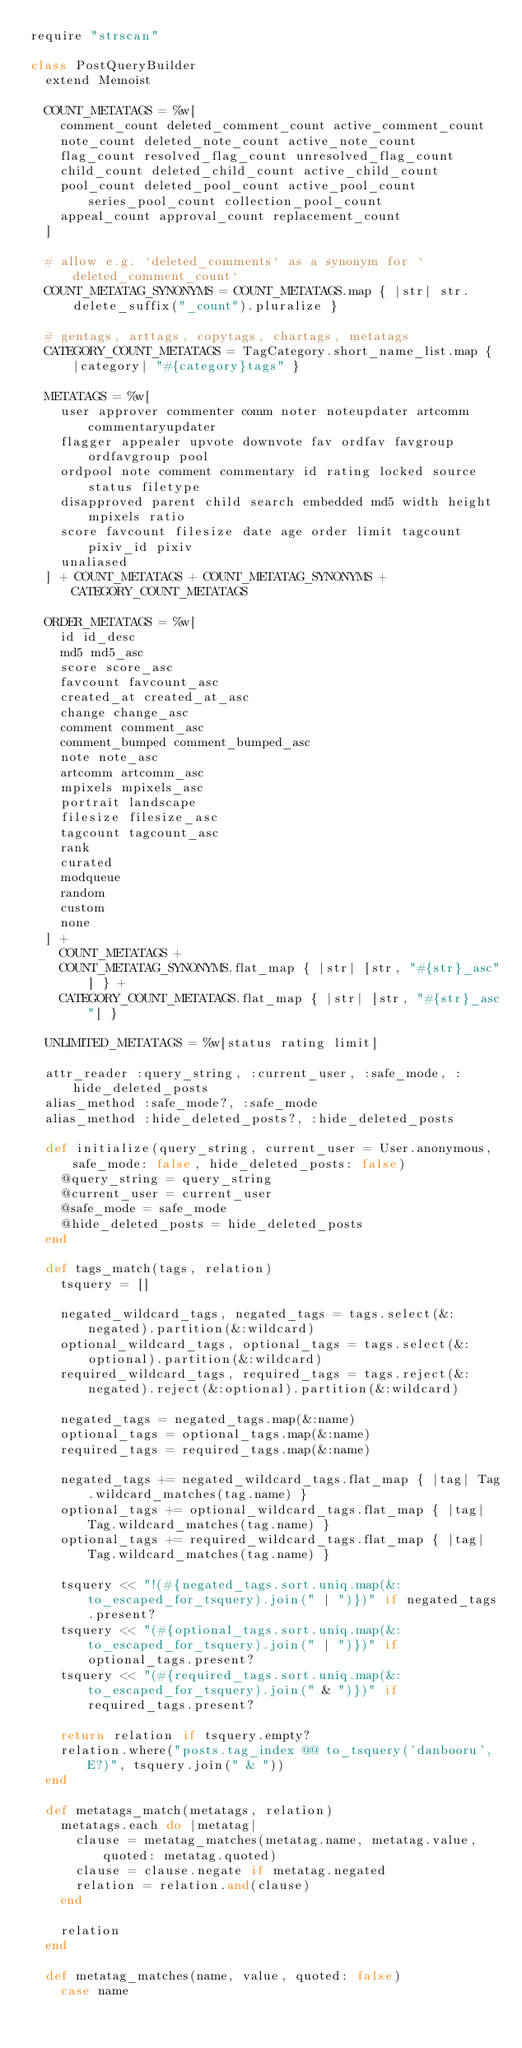Convert code to text. <code><loc_0><loc_0><loc_500><loc_500><_Ruby_>require "strscan"

class PostQueryBuilder
  extend Memoist

  COUNT_METATAGS = %w[
    comment_count deleted_comment_count active_comment_count
    note_count deleted_note_count active_note_count
    flag_count resolved_flag_count unresolved_flag_count
    child_count deleted_child_count active_child_count
    pool_count deleted_pool_count active_pool_count series_pool_count collection_pool_count
    appeal_count approval_count replacement_count
  ]

  # allow e.g. `deleted_comments` as a synonym for `deleted_comment_count`
  COUNT_METATAG_SYNONYMS = COUNT_METATAGS.map { |str| str.delete_suffix("_count").pluralize }

  # gentags, arttags, copytags, chartags, metatags
  CATEGORY_COUNT_METATAGS = TagCategory.short_name_list.map { |category| "#{category}tags" }

  METATAGS = %w[
    user approver commenter comm noter noteupdater artcomm commentaryupdater
    flagger appealer upvote downvote fav ordfav favgroup ordfavgroup pool
    ordpool note comment commentary id rating locked source status filetype
    disapproved parent child search embedded md5 width height mpixels ratio
    score favcount filesize date age order limit tagcount pixiv_id pixiv
    unaliased
  ] + COUNT_METATAGS + COUNT_METATAG_SYNONYMS + CATEGORY_COUNT_METATAGS

  ORDER_METATAGS = %w[
    id id_desc
    md5 md5_asc
    score score_asc
    favcount favcount_asc
    created_at created_at_asc
    change change_asc
    comment comment_asc
    comment_bumped comment_bumped_asc
    note note_asc
    artcomm artcomm_asc
    mpixels mpixels_asc
    portrait landscape
    filesize filesize_asc
    tagcount tagcount_asc
    rank
    curated
    modqueue
    random
    custom
    none
  ] +
    COUNT_METATAGS +
    COUNT_METATAG_SYNONYMS.flat_map { |str| [str, "#{str}_asc"] } +
    CATEGORY_COUNT_METATAGS.flat_map { |str| [str, "#{str}_asc"] }

  UNLIMITED_METATAGS = %w[status rating limit]

  attr_reader :query_string, :current_user, :safe_mode, :hide_deleted_posts
  alias_method :safe_mode?, :safe_mode
  alias_method :hide_deleted_posts?, :hide_deleted_posts

  def initialize(query_string, current_user = User.anonymous, safe_mode: false, hide_deleted_posts: false)
    @query_string = query_string
    @current_user = current_user
    @safe_mode = safe_mode
    @hide_deleted_posts = hide_deleted_posts
  end

  def tags_match(tags, relation)
    tsquery = []

    negated_wildcard_tags, negated_tags = tags.select(&:negated).partition(&:wildcard)
    optional_wildcard_tags, optional_tags = tags.select(&:optional).partition(&:wildcard)
    required_wildcard_tags, required_tags = tags.reject(&:negated).reject(&:optional).partition(&:wildcard)

    negated_tags = negated_tags.map(&:name)
    optional_tags = optional_tags.map(&:name)
    required_tags = required_tags.map(&:name)

    negated_tags += negated_wildcard_tags.flat_map { |tag| Tag.wildcard_matches(tag.name) }
    optional_tags += optional_wildcard_tags.flat_map { |tag| Tag.wildcard_matches(tag.name) }
    optional_tags += required_wildcard_tags.flat_map { |tag| Tag.wildcard_matches(tag.name) }

    tsquery << "!(#{negated_tags.sort.uniq.map(&:to_escaped_for_tsquery).join(" | ")})" if negated_tags.present?
    tsquery << "(#{optional_tags.sort.uniq.map(&:to_escaped_for_tsquery).join(" | ")})" if optional_tags.present?
    tsquery << "(#{required_tags.sort.uniq.map(&:to_escaped_for_tsquery).join(" & ")})" if required_tags.present?

    return relation if tsquery.empty?
    relation.where("posts.tag_index @@ to_tsquery('danbooru', E?)", tsquery.join(" & "))
  end

  def metatags_match(metatags, relation)
    metatags.each do |metatag|
      clause = metatag_matches(metatag.name, metatag.value, quoted: metatag.quoted)
      clause = clause.negate if metatag.negated
      relation = relation.and(clause)
    end

    relation
  end

  def metatag_matches(name, value, quoted: false)
    case name</code> 